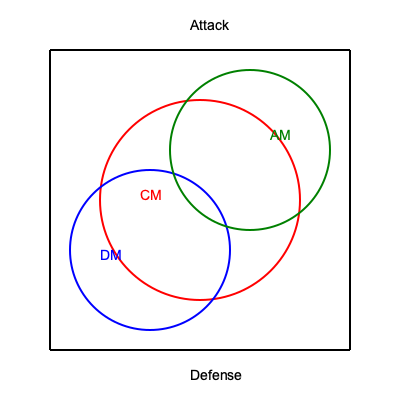In the given diagram representing a football pitch with overlapping zones of influence for different player positions, which area represents the most crucial space for implementing the Dutch-inspired Barcelona style of play, considering the interaction between the Central Midfielder (CM), Defensive Midfielder (DM), and Attacking Midfielder (AM)? To answer this question, we need to analyze the overlapping zones and their significance in the Dutch-inspired Barcelona style:

1. The red circle represents the Central Midfielder's (CM) zone of influence.
2. The blue circle represents the Defensive Midfielder's (DM) zone of influence.
3. The green circle represents the Attacking Midfielder's (AM) zone of influence.

The Dutch-inspired Barcelona style, often referred to as "Total Football," emphasizes:

a) Fluid positioning and interchangeability of players
b) Quick, short passing
c) Control of the center of the pitch

The most crucial area for implementing this style would be where all three zones intersect, as this represents:

1. The heart of the midfield, where possession is maintained and controlled.
2. The area where quick, short passes can be most effectively executed between these three key positions.
3. The space that allows for fluid movement and positional interchangeability among the CM, DM, and AM.

This central overlapping area facilitates the core principles of the Dutch-inspired Barcelona style, enabling:

- Triangular passing options
- Press-resistant positioning
- Quick transitions between defense and attack

Therefore, the area where all three circles overlap is the most crucial for implementing this playing style.
Answer: The central area where CM, DM, and AM zones intersect 